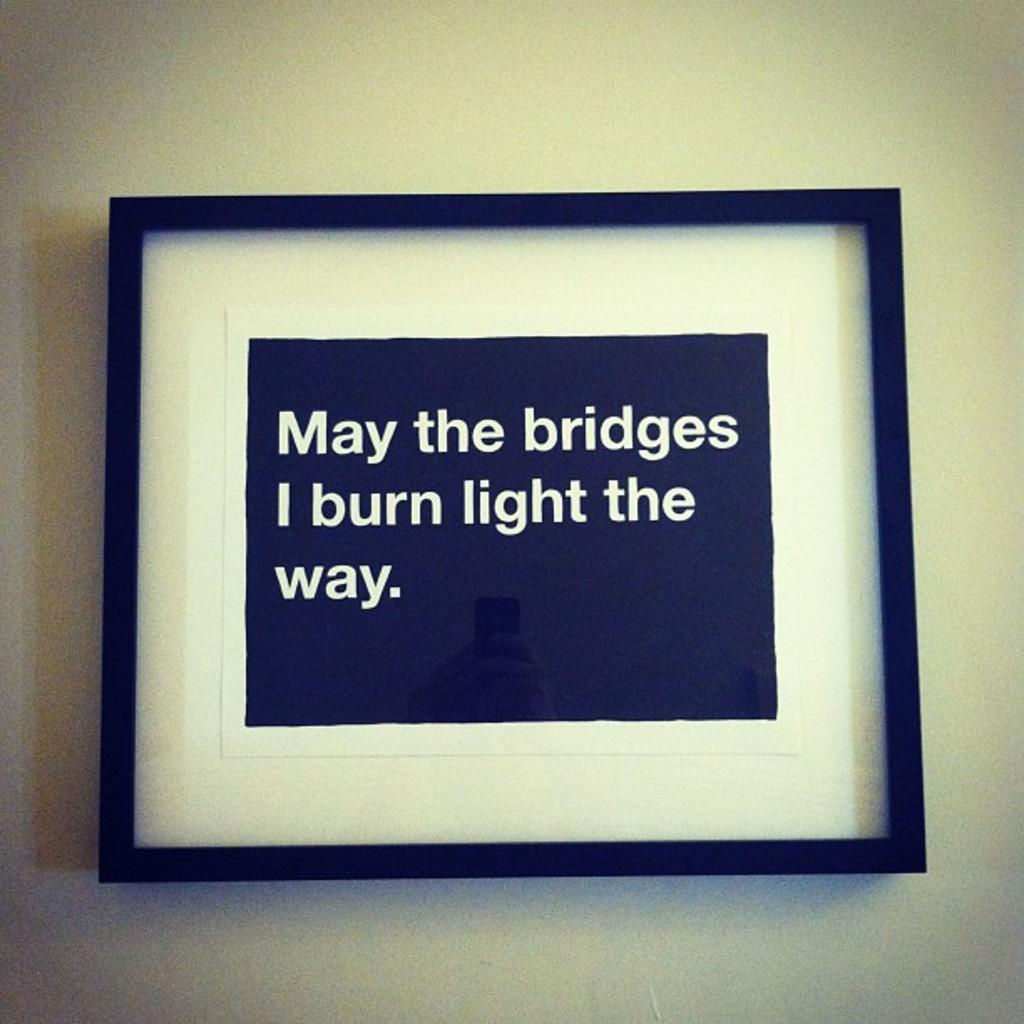<image>
Write a terse but informative summary of the picture. A framed sign says "May the bridges I burn light the way." 